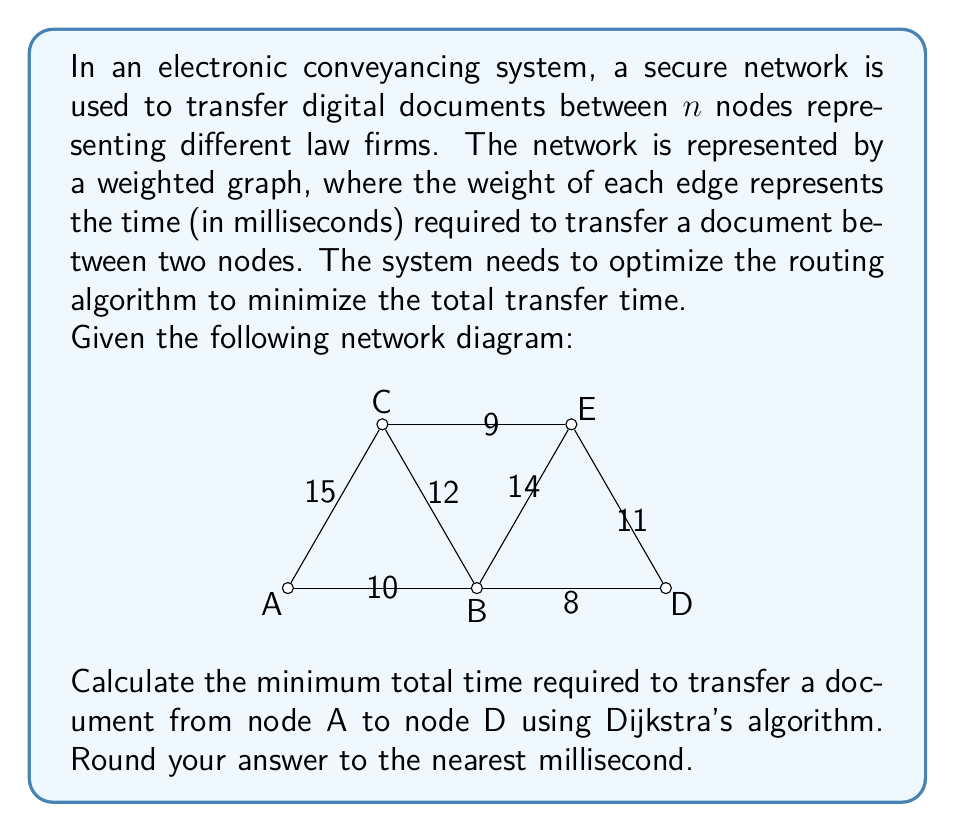Can you solve this math problem? To solve this problem, we'll use Dijkstra's algorithm to find the shortest path from node A to node D. Here's a step-by-step explanation:

1. Initialize:
   - Set distance to A as 0
   - Set distances to all other nodes as infinity
   - Set all nodes as unvisited

2. Start with node A:
   - Update distances to neighboring nodes:
     B: min(∞, 0 + 10) = 10
     C: min(∞, 0 + 15) = 15

3. Select the unvisited node with the smallest distance (B):
   - Update distances to B's neighbors:
     C: min(15, 10 + 12) = 15 (no change)
     D: min(∞, 10 + 8) = 18
     E: min(∞, 10 + 14) = 24

4. Select the unvisited node with the smallest distance (C):
   - Update distances to C's neighbors:
     E: min(24, 15 + 9) = 24 (no change)

5. Select the unvisited node with the smallest distance (D):
   - All nodes connecting to D have been visited, so no updates are needed

6. The algorithm terminates as we've reached node D

The shortest path from A to D is: A → B → D
The total time for this path is: 10 + 8 = 18 milliseconds

Therefore, the minimum total time required to transfer a document from node A to node D is 18 milliseconds.
Answer: 18 ms 